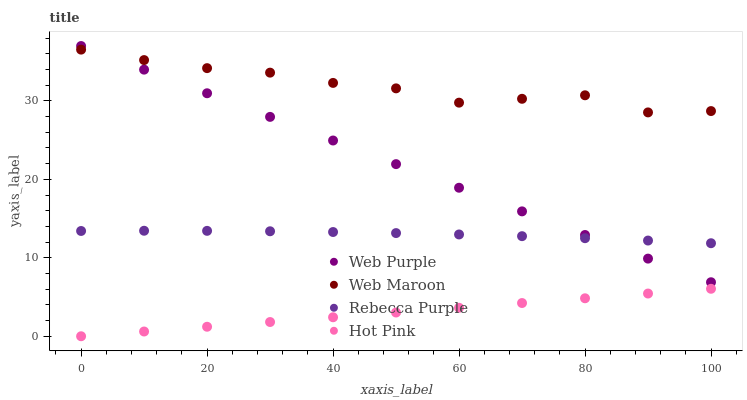Does Hot Pink have the minimum area under the curve?
Answer yes or no. Yes. Does Web Maroon have the maximum area under the curve?
Answer yes or no. Yes. Does Web Maroon have the minimum area under the curve?
Answer yes or no. No. Does Hot Pink have the maximum area under the curve?
Answer yes or no. No. Is Web Purple the smoothest?
Answer yes or no. Yes. Is Web Maroon the roughest?
Answer yes or no. Yes. Is Hot Pink the smoothest?
Answer yes or no. No. Is Hot Pink the roughest?
Answer yes or no. No. Does Hot Pink have the lowest value?
Answer yes or no. Yes. Does Web Maroon have the lowest value?
Answer yes or no. No. Does Web Purple have the highest value?
Answer yes or no. Yes. Does Web Maroon have the highest value?
Answer yes or no. No. Is Hot Pink less than Web Purple?
Answer yes or no. Yes. Is Rebecca Purple greater than Hot Pink?
Answer yes or no. Yes. Does Rebecca Purple intersect Web Purple?
Answer yes or no. Yes. Is Rebecca Purple less than Web Purple?
Answer yes or no. No. Is Rebecca Purple greater than Web Purple?
Answer yes or no. No. Does Hot Pink intersect Web Purple?
Answer yes or no. No. 